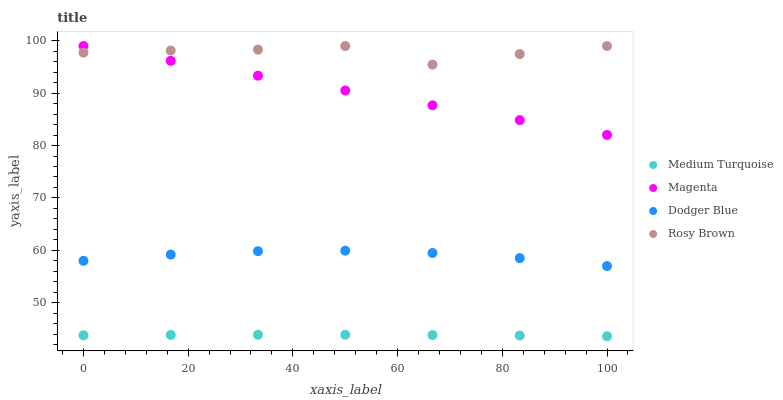Does Medium Turquoise have the minimum area under the curve?
Answer yes or no. Yes. Does Rosy Brown have the maximum area under the curve?
Answer yes or no. Yes. Does Dodger Blue have the minimum area under the curve?
Answer yes or no. No. Does Dodger Blue have the maximum area under the curve?
Answer yes or no. No. Is Magenta the smoothest?
Answer yes or no. Yes. Is Rosy Brown the roughest?
Answer yes or no. Yes. Is Dodger Blue the smoothest?
Answer yes or no. No. Is Dodger Blue the roughest?
Answer yes or no. No. Does Medium Turquoise have the lowest value?
Answer yes or no. Yes. Does Dodger Blue have the lowest value?
Answer yes or no. No. Does Rosy Brown have the highest value?
Answer yes or no. Yes. Does Dodger Blue have the highest value?
Answer yes or no. No. Is Dodger Blue less than Magenta?
Answer yes or no. Yes. Is Magenta greater than Dodger Blue?
Answer yes or no. Yes. Does Magenta intersect Rosy Brown?
Answer yes or no. Yes. Is Magenta less than Rosy Brown?
Answer yes or no. No. Is Magenta greater than Rosy Brown?
Answer yes or no. No. Does Dodger Blue intersect Magenta?
Answer yes or no. No. 